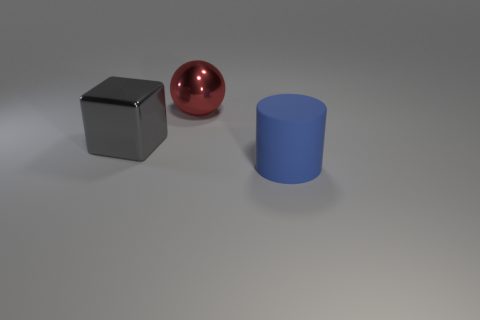Add 2 big yellow metal blocks. How many objects exist? 5 Subtract all blocks. How many objects are left? 2 Add 2 small purple blocks. How many small purple blocks exist? 2 Subtract 0 brown spheres. How many objects are left? 3 Subtract all large red things. Subtract all large blue cylinders. How many objects are left? 1 Add 3 big metal cubes. How many big metal cubes are left? 4 